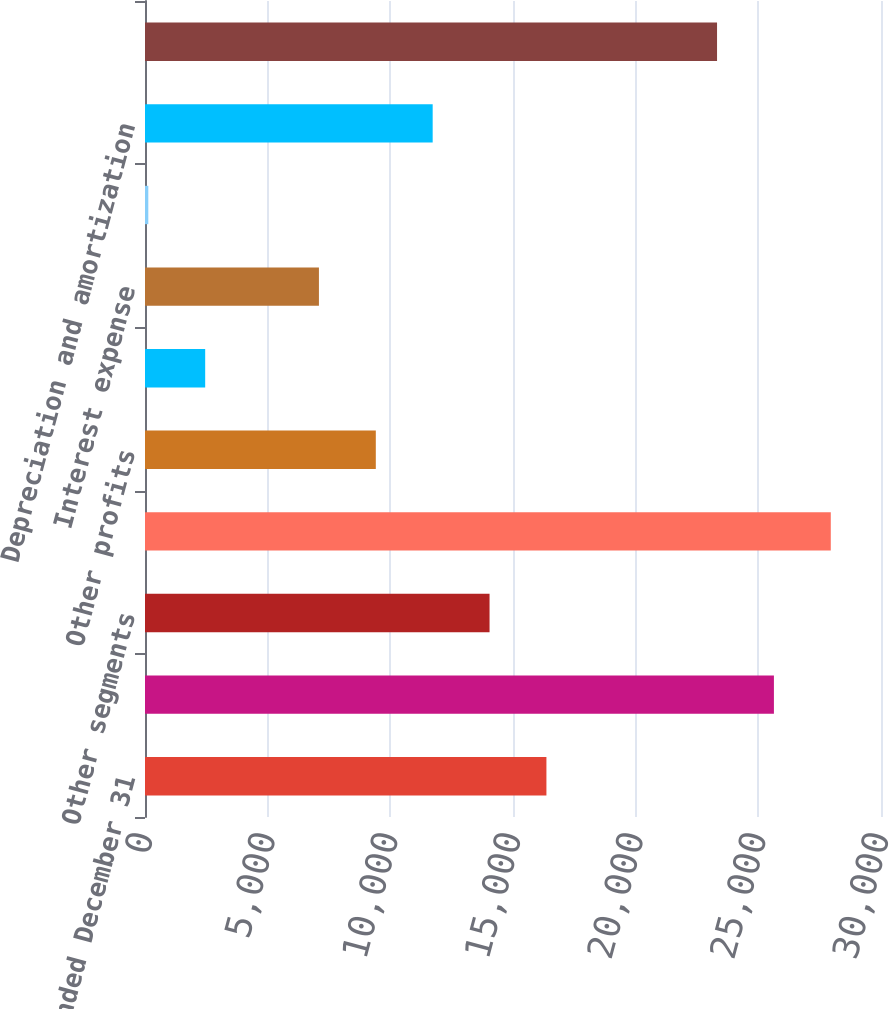<chart> <loc_0><loc_0><loc_500><loc_500><bar_chart><fcel>Years Ended December 31<fcel>Pharmaceutical segment<fcel>Other segments<fcel>Total segment profits<fcel>Other profits<fcel>Interest income<fcel>Interest expense<fcel>Equity income from affiliates<fcel>Depreciation and amortization<fcel>Research and development<nl><fcel>16362.4<fcel>25635.2<fcel>14044.2<fcel>27953.4<fcel>9407.8<fcel>2453.2<fcel>7089.6<fcel>135<fcel>11726<fcel>23317<nl></chart> 